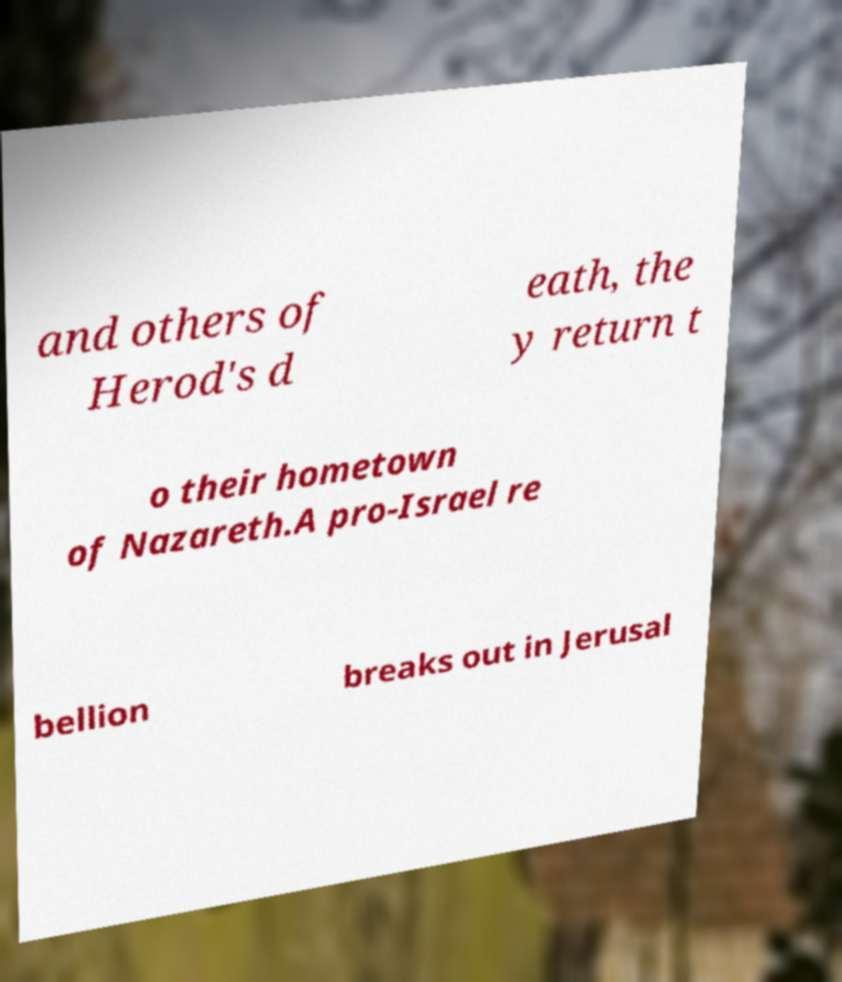For documentation purposes, I need the text within this image transcribed. Could you provide that? and others of Herod's d eath, the y return t o their hometown of Nazareth.A pro-Israel re bellion breaks out in Jerusal 